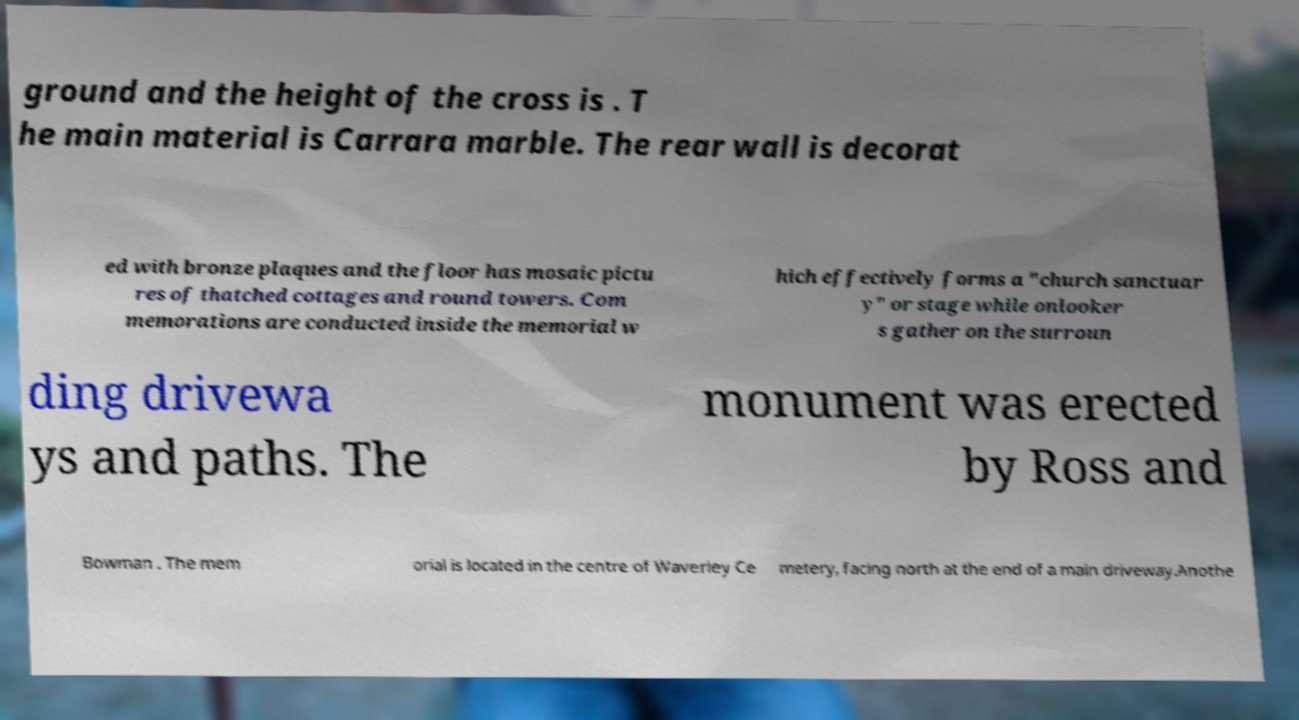What messages or text are displayed in this image? I need them in a readable, typed format. ground and the height of the cross is . T he main material is Carrara marble. The rear wall is decorat ed with bronze plaques and the floor has mosaic pictu res of thatched cottages and round towers. Com memorations are conducted inside the memorial w hich effectively forms a "church sanctuar y" or stage while onlooker s gather on the surroun ding drivewa ys and paths. The monument was erected by Ross and Bowman . The mem orial is located in the centre of Waverley Ce metery, facing north at the end of a main driveway.Anothe 